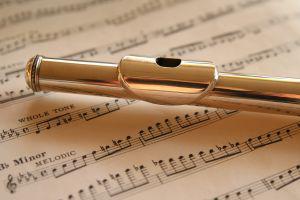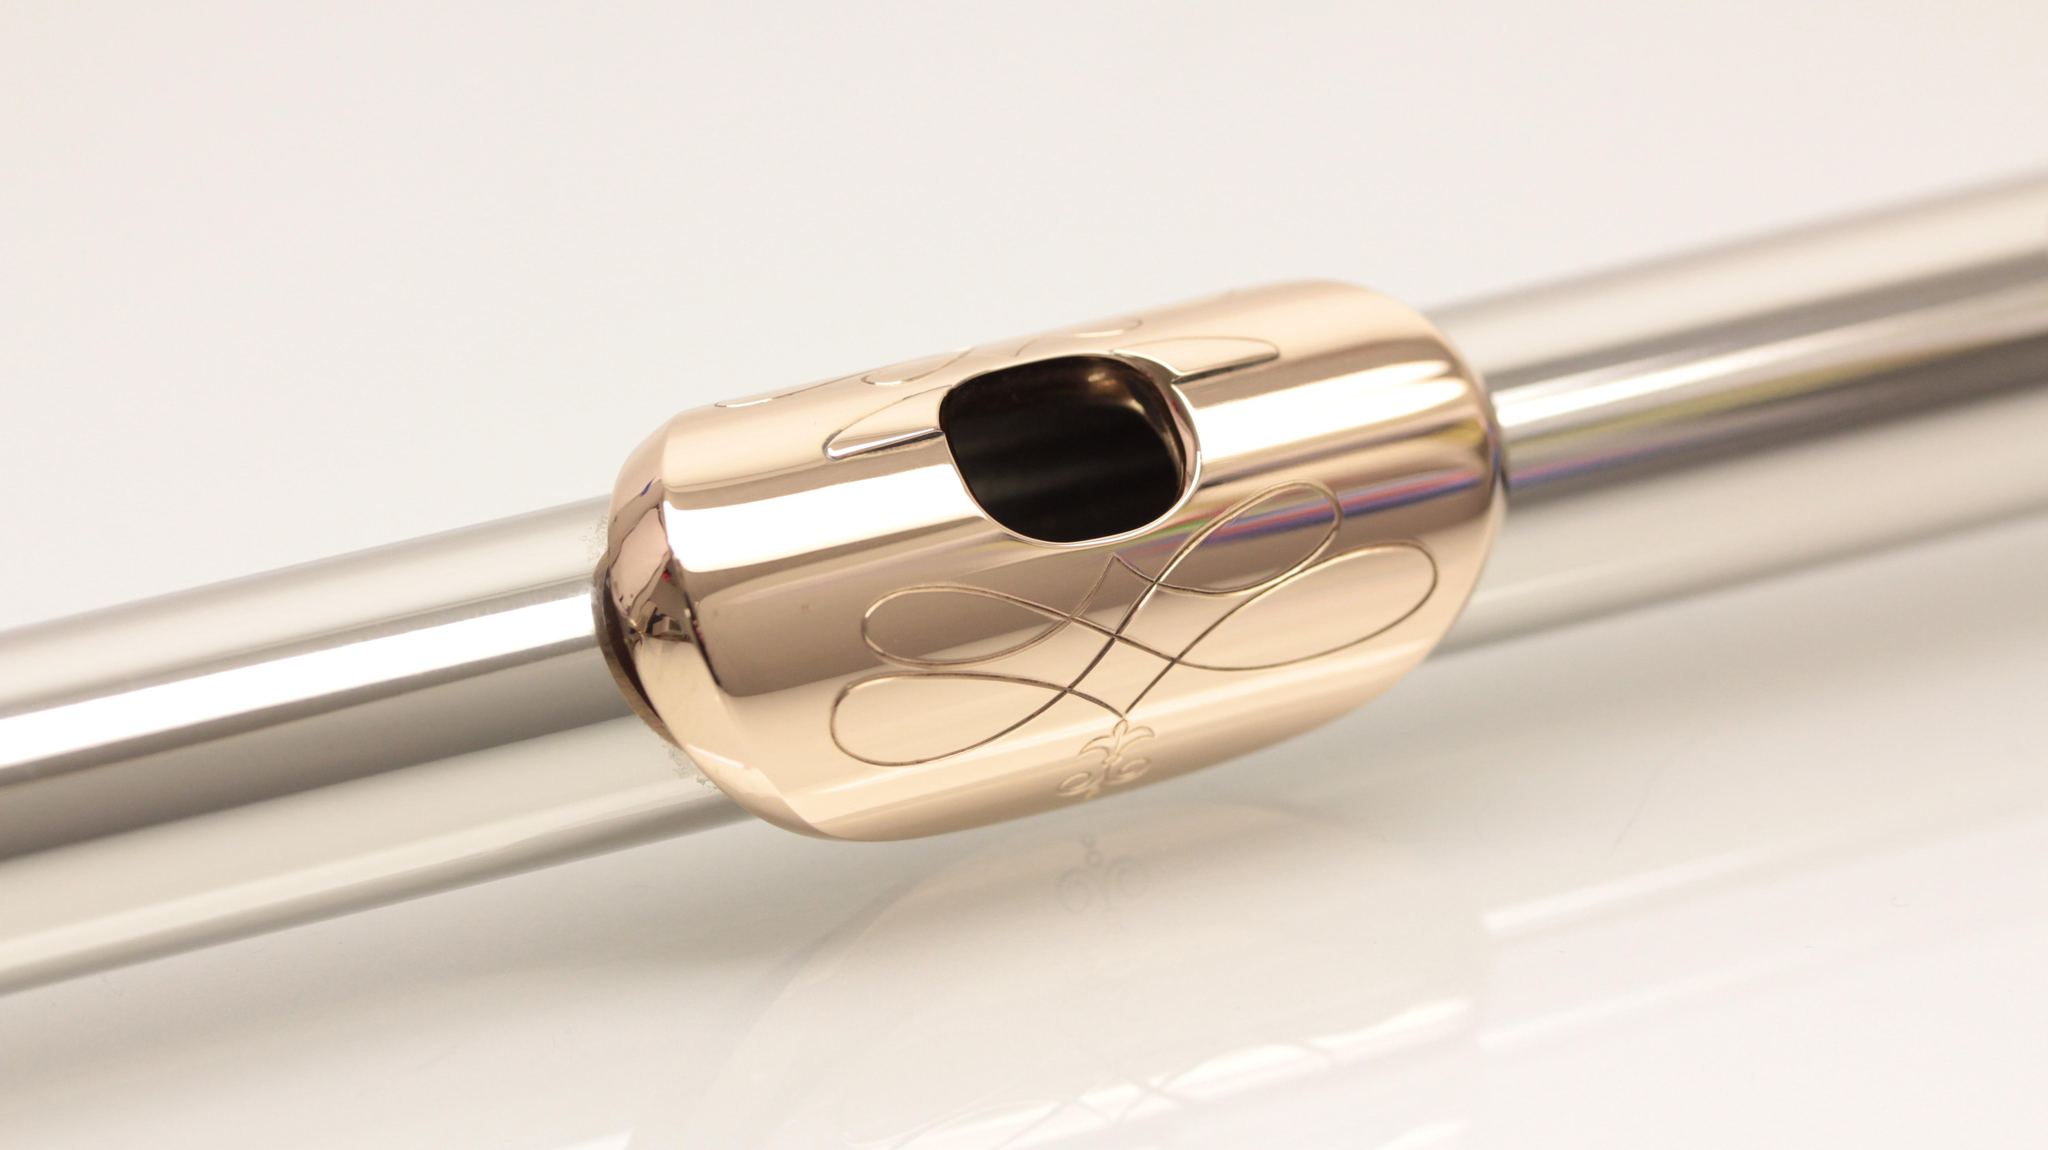The first image is the image on the left, the second image is the image on the right. Assess this claim about the two images: "The right image shows a silver tube angled upward to the right, with a gold oblong shape with a hole in it near the middle of the tube.". Correct or not? Answer yes or no. Yes. The first image is the image on the left, the second image is the image on the right. Analyze the images presented: Is the assertion "In the right image, the instrument mouthpiece is gold colored on a silver body." valid? Answer yes or no. Yes. 